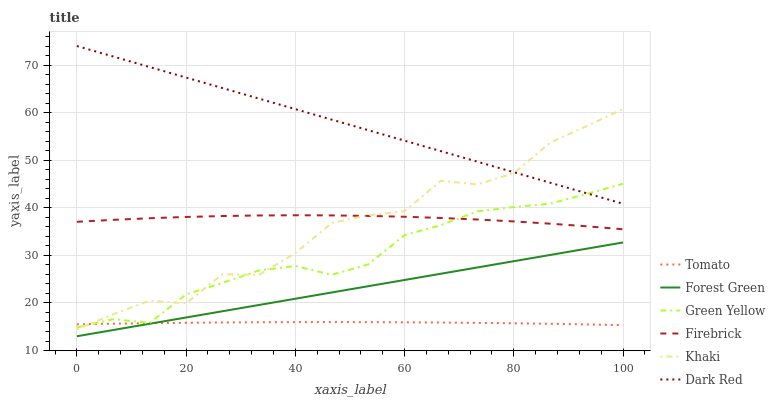Does Khaki have the minimum area under the curve?
Answer yes or no. No. Does Khaki have the maximum area under the curve?
Answer yes or no. No. Is Dark Red the smoothest?
Answer yes or no. No. Is Dark Red the roughest?
Answer yes or no. No. Does Khaki have the lowest value?
Answer yes or no. No. Does Khaki have the highest value?
Answer yes or no. No. Is Tomato less than Firebrick?
Answer yes or no. Yes. Is Dark Red greater than Tomato?
Answer yes or no. Yes. Does Tomato intersect Firebrick?
Answer yes or no. No. 